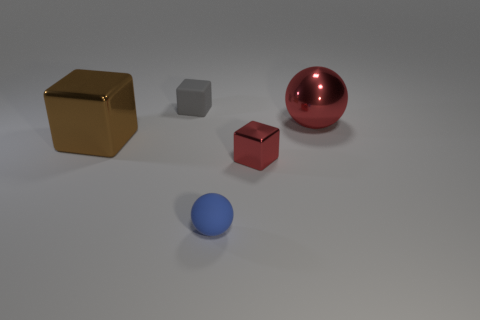What is the color of the large metal thing that is to the left of the tiny block that is right of the sphere in front of the red block?
Ensure brevity in your answer.  Brown. How many things are metal things that are right of the small gray object or small blue matte objects in front of the big red ball?
Provide a short and direct response. 3. What number of other things are the same color as the big sphere?
Offer a very short reply. 1. Does the tiny object that is left of the tiny blue rubber ball have the same shape as the big brown object?
Your answer should be compact. Yes. Is the number of metallic objects that are right of the tiny red metallic cube less than the number of things?
Provide a succinct answer. Yes. Are there any tiny brown cylinders made of the same material as the big red ball?
Your response must be concise. No. What is the material of the blue ball that is the same size as the red cube?
Your answer should be very brief. Rubber. Are there fewer big brown objects right of the tiny matte sphere than spheres that are in front of the big brown object?
Give a very brief answer. Yes. What is the shape of the object that is behind the blue rubber thing and in front of the big brown metallic block?
Give a very brief answer. Cube. What number of small purple metal objects are the same shape as the tiny gray rubber object?
Offer a terse response. 0. 